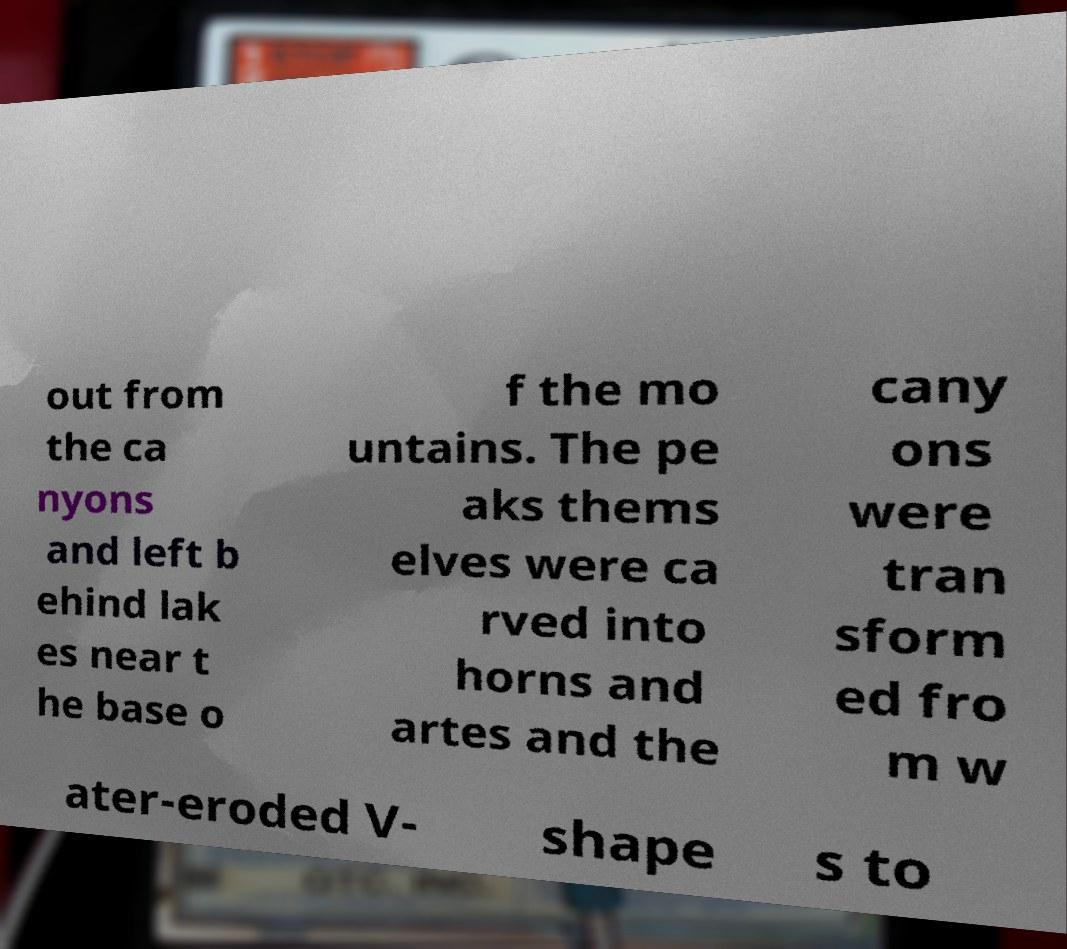For documentation purposes, I need the text within this image transcribed. Could you provide that? out from the ca nyons and left b ehind lak es near t he base o f the mo untains. The pe aks thems elves were ca rved into horns and artes and the cany ons were tran sform ed fro m w ater-eroded V- shape s to 